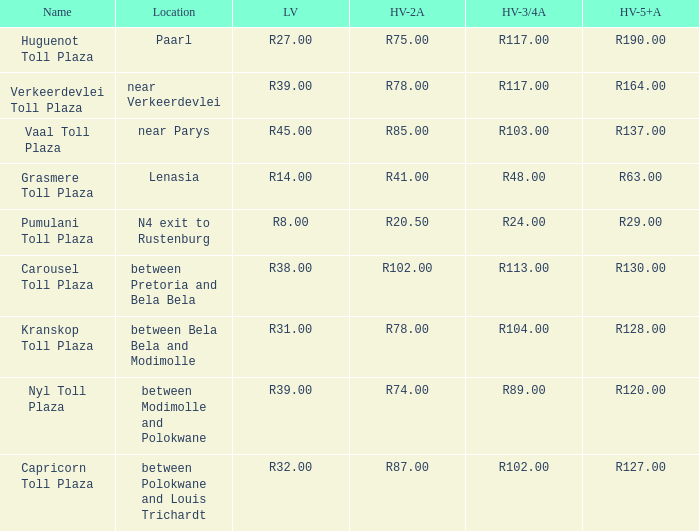Can you parse all the data within this table? {'header': ['Name', 'Location', 'LV', 'HV-2A', 'HV-3/4A', 'HV-5+A'], 'rows': [['Huguenot Toll Plaza', 'Paarl', 'R27.00', 'R75.00', 'R117.00', 'R190.00'], ['Verkeerdevlei Toll Plaza', 'near Verkeerdevlei', 'R39.00', 'R78.00', 'R117.00', 'R164.00'], ['Vaal Toll Plaza', 'near Parys', 'R45.00', 'R85.00', 'R103.00', 'R137.00'], ['Grasmere Toll Plaza', 'Lenasia', 'R14.00', 'R41.00', 'R48.00', 'R63.00'], ['Pumulani Toll Plaza', 'N4 exit to Rustenburg', 'R8.00', 'R20.50', 'R24.00', 'R29.00'], ['Carousel Toll Plaza', 'between Pretoria and Bela Bela', 'R38.00', 'R102.00', 'R113.00', 'R130.00'], ['Kranskop Toll Plaza', 'between Bela Bela and Modimolle', 'R31.00', 'R78.00', 'R104.00', 'R128.00'], ['Nyl Toll Plaza', 'between Modimolle and Polokwane', 'R39.00', 'R74.00', 'R89.00', 'R120.00'], ['Capricorn Toll Plaza', 'between Polokwane and Louis Trichardt', 'R32.00', 'R87.00', 'R102.00', 'R127.00']]} What is the toll for heavy vehicles with 3/4 axles at Verkeerdevlei toll plaza? R117.00. 